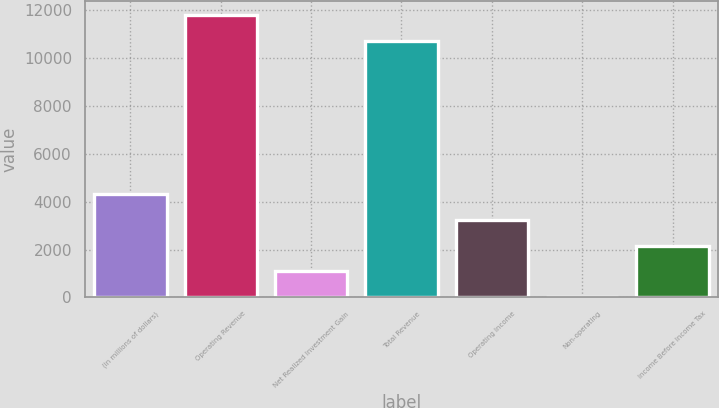Convert chart. <chart><loc_0><loc_0><loc_500><loc_500><bar_chart><fcel>(in millions of dollars)<fcel>Operating Revenue<fcel>Net Realized Investment Gain<fcel>Total Revenue<fcel>Operating Income<fcel>Non-operating<fcel>Income Before Income Tax<nl><fcel>4317.18<fcel>11807.6<fcel>1088.22<fcel>10731.3<fcel>3240.86<fcel>11.9<fcel>2164.54<nl></chart> 